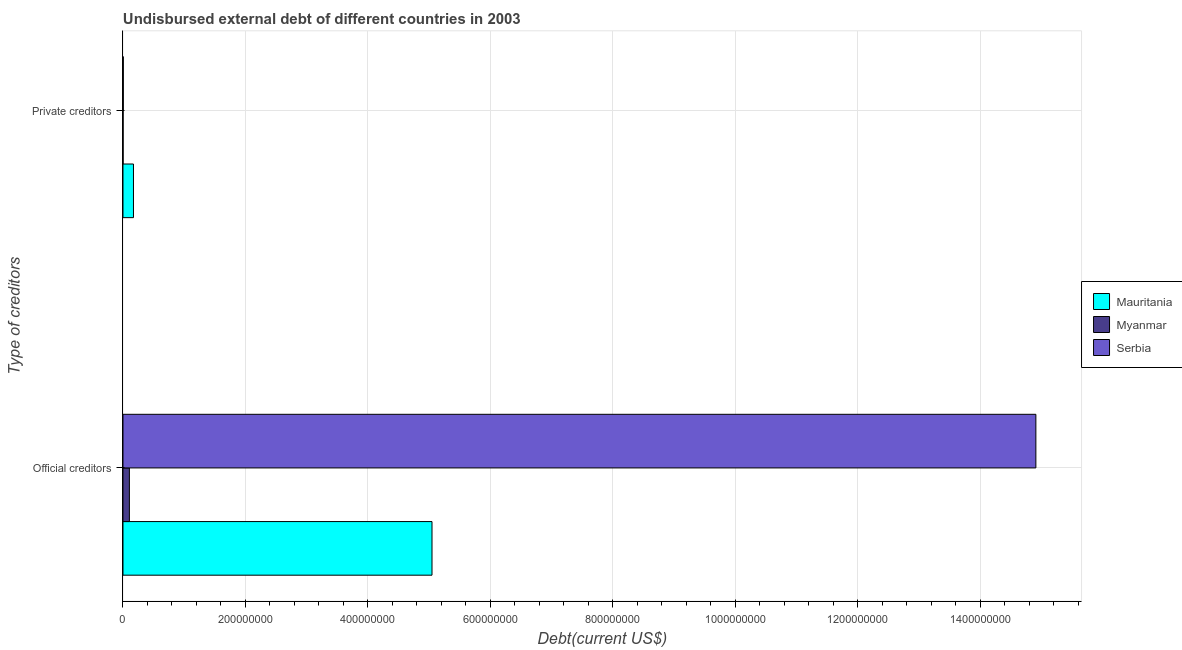How many different coloured bars are there?
Give a very brief answer. 3. How many groups of bars are there?
Ensure brevity in your answer.  2. Are the number of bars per tick equal to the number of legend labels?
Keep it short and to the point. Yes. Are the number of bars on each tick of the Y-axis equal?
Offer a very short reply. Yes. How many bars are there on the 1st tick from the bottom?
Your answer should be compact. 3. What is the label of the 1st group of bars from the top?
Your response must be concise. Private creditors. What is the undisbursed external debt of private creditors in Mauritania?
Keep it short and to the point. 1.71e+07. Across all countries, what is the maximum undisbursed external debt of official creditors?
Give a very brief answer. 1.49e+09. Across all countries, what is the minimum undisbursed external debt of official creditors?
Offer a very short reply. 1.05e+07. In which country was the undisbursed external debt of private creditors maximum?
Offer a very short reply. Mauritania. In which country was the undisbursed external debt of private creditors minimum?
Make the answer very short. Myanmar. What is the total undisbursed external debt of official creditors in the graph?
Offer a terse response. 2.01e+09. What is the difference between the undisbursed external debt of private creditors in Myanmar and that in Serbia?
Your answer should be compact. -3.42e+05. What is the difference between the undisbursed external debt of official creditors in Serbia and the undisbursed external debt of private creditors in Myanmar?
Provide a short and direct response. 1.49e+09. What is the average undisbursed external debt of private creditors per country?
Provide a succinct answer. 5.93e+06. What is the difference between the undisbursed external debt of official creditors and undisbursed external debt of private creditors in Myanmar?
Provide a succinct answer. 1.03e+07. What is the ratio of the undisbursed external debt of private creditors in Myanmar to that in Serbia?
Provide a short and direct response. 0.32. Is the undisbursed external debt of private creditors in Mauritania less than that in Serbia?
Keep it short and to the point. No. What does the 3rd bar from the top in Private creditors represents?
Offer a terse response. Mauritania. What does the 2nd bar from the bottom in Private creditors represents?
Your response must be concise. Myanmar. What is the difference between two consecutive major ticks on the X-axis?
Keep it short and to the point. 2.00e+08. Are the values on the major ticks of X-axis written in scientific E-notation?
Your answer should be compact. No. Does the graph contain grids?
Keep it short and to the point. Yes. How many legend labels are there?
Give a very brief answer. 3. How are the legend labels stacked?
Make the answer very short. Vertical. What is the title of the graph?
Offer a very short reply. Undisbursed external debt of different countries in 2003. What is the label or title of the X-axis?
Your response must be concise. Debt(current US$). What is the label or title of the Y-axis?
Offer a terse response. Type of creditors. What is the Debt(current US$) in Mauritania in Official creditors?
Provide a succinct answer. 5.05e+08. What is the Debt(current US$) in Myanmar in Official creditors?
Your answer should be compact. 1.05e+07. What is the Debt(current US$) in Serbia in Official creditors?
Make the answer very short. 1.49e+09. What is the Debt(current US$) in Mauritania in Private creditors?
Keep it short and to the point. 1.71e+07. What is the Debt(current US$) of Myanmar in Private creditors?
Offer a very short reply. 1.63e+05. What is the Debt(current US$) of Serbia in Private creditors?
Keep it short and to the point. 5.05e+05. Across all Type of creditors, what is the maximum Debt(current US$) in Mauritania?
Ensure brevity in your answer.  5.05e+08. Across all Type of creditors, what is the maximum Debt(current US$) in Myanmar?
Ensure brevity in your answer.  1.05e+07. Across all Type of creditors, what is the maximum Debt(current US$) in Serbia?
Give a very brief answer. 1.49e+09. Across all Type of creditors, what is the minimum Debt(current US$) of Mauritania?
Offer a very short reply. 1.71e+07. Across all Type of creditors, what is the minimum Debt(current US$) of Myanmar?
Ensure brevity in your answer.  1.63e+05. Across all Type of creditors, what is the minimum Debt(current US$) in Serbia?
Make the answer very short. 5.05e+05. What is the total Debt(current US$) of Mauritania in the graph?
Provide a short and direct response. 5.22e+08. What is the total Debt(current US$) in Myanmar in the graph?
Offer a very short reply. 1.06e+07. What is the total Debt(current US$) in Serbia in the graph?
Keep it short and to the point. 1.49e+09. What is the difference between the Debt(current US$) of Mauritania in Official creditors and that in Private creditors?
Provide a short and direct response. 4.88e+08. What is the difference between the Debt(current US$) in Myanmar in Official creditors and that in Private creditors?
Make the answer very short. 1.03e+07. What is the difference between the Debt(current US$) in Serbia in Official creditors and that in Private creditors?
Provide a succinct answer. 1.49e+09. What is the difference between the Debt(current US$) of Mauritania in Official creditors and the Debt(current US$) of Myanmar in Private creditors?
Keep it short and to the point. 5.05e+08. What is the difference between the Debt(current US$) in Mauritania in Official creditors and the Debt(current US$) in Serbia in Private creditors?
Your response must be concise. 5.04e+08. What is the difference between the Debt(current US$) of Myanmar in Official creditors and the Debt(current US$) of Serbia in Private creditors?
Provide a short and direct response. 9.97e+06. What is the average Debt(current US$) of Mauritania per Type of creditors?
Provide a short and direct response. 2.61e+08. What is the average Debt(current US$) in Myanmar per Type of creditors?
Offer a terse response. 5.32e+06. What is the average Debt(current US$) of Serbia per Type of creditors?
Offer a terse response. 7.46e+08. What is the difference between the Debt(current US$) in Mauritania and Debt(current US$) in Myanmar in Official creditors?
Provide a short and direct response. 4.94e+08. What is the difference between the Debt(current US$) of Mauritania and Debt(current US$) of Serbia in Official creditors?
Keep it short and to the point. -9.86e+08. What is the difference between the Debt(current US$) of Myanmar and Debt(current US$) of Serbia in Official creditors?
Provide a short and direct response. -1.48e+09. What is the difference between the Debt(current US$) in Mauritania and Debt(current US$) in Myanmar in Private creditors?
Offer a terse response. 1.70e+07. What is the difference between the Debt(current US$) in Mauritania and Debt(current US$) in Serbia in Private creditors?
Offer a very short reply. 1.66e+07. What is the difference between the Debt(current US$) in Myanmar and Debt(current US$) in Serbia in Private creditors?
Keep it short and to the point. -3.42e+05. What is the ratio of the Debt(current US$) in Mauritania in Official creditors to that in Private creditors?
Offer a terse response. 29.48. What is the ratio of the Debt(current US$) of Myanmar in Official creditors to that in Private creditors?
Give a very brief answer. 64.28. What is the ratio of the Debt(current US$) of Serbia in Official creditors to that in Private creditors?
Your answer should be compact. 2952.32. What is the difference between the highest and the second highest Debt(current US$) in Mauritania?
Provide a short and direct response. 4.88e+08. What is the difference between the highest and the second highest Debt(current US$) of Myanmar?
Ensure brevity in your answer.  1.03e+07. What is the difference between the highest and the second highest Debt(current US$) in Serbia?
Provide a short and direct response. 1.49e+09. What is the difference between the highest and the lowest Debt(current US$) in Mauritania?
Offer a terse response. 4.88e+08. What is the difference between the highest and the lowest Debt(current US$) of Myanmar?
Offer a terse response. 1.03e+07. What is the difference between the highest and the lowest Debt(current US$) of Serbia?
Make the answer very short. 1.49e+09. 